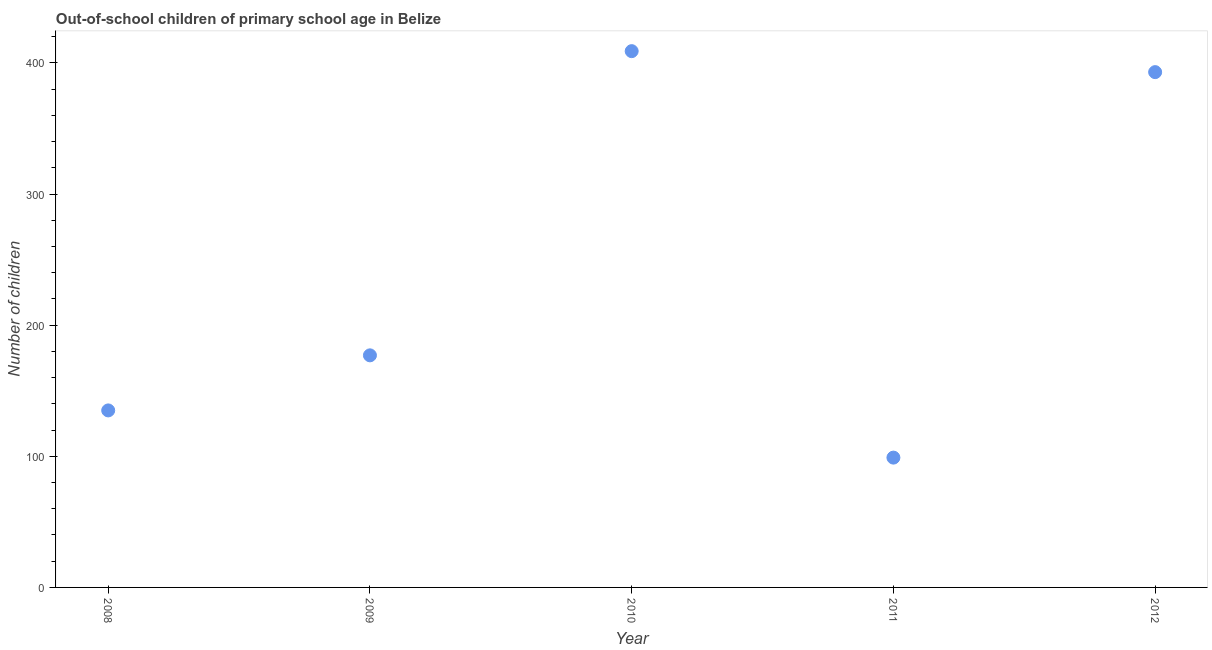What is the number of out-of-school children in 2010?
Give a very brief answer. 409. Across all years, what is the maximum number of out-of-school children?
Your answer should be compact. 409. Across all years, what is the minimum number of out-of-school children?
Provide a short and direct response. 99. In which year was the number of out-of-school children minimum?
Ensure brevity in your answer.  2011. What is the sum of the number of out-of-school children?
Your answer should be very brief. 1213. What is the difference between the number of out-of-school children in 2011 and 2012?
Your answer should be very brief. -294. What is the average number of out-of-school children per year?
Provide a succinct answer. 242.6. What is the median number of out-of-school children?
Keep it short and to the point. 177. In how many years, is the number of out-of-school children greater than 260 ?
Offer a very short reply. 2. What is the ratio of the number of out-of-school children in 2010 to that in 2011?
Provide a short and direct response. 4.13. What is the difference between the highest and the second highest number of out-of-school children?
Your answer should be very brief. 16. What is the difference between the highest and the lowest number of out-of-school children?
Provide a short and direct response. 310. In how many years, is the number of out-of-school children greater than the average number of out-of-school children taken over all years?
Provide a short and direct response. 2. Does the number of out-of-school children monotonically increase over the years?
Offer a very short reply. No. Are the values on the major ticks of Y-axis written in scientific E-notation?
Your response must be concise. No. Does the graph contain any zero values?
Give a very brief answer. No. What is the title of the graph?
Your answer should be very brief. Out-of-school children of primary school age in Belize. What is the label or title of the Y-axis?
Provide a succinct answer. Number of children. What is the Number of children in 2008?
Make the answer very short. 135. What is the Number of children in 2009?
Keep it short and to the point. 177. What is the Number of children in 2010?
Your answer should be very brief. 409. What is the Number of children in 2011?
Offer a very short reply. 99. What is the Number of children in 2012?
Provide a short and direct response. 393. What is the difference between the Number of children in 2008 and 2009?
Provide a succinct answer. -42. What is the difference between the Number of children in 2008 and 2010?
Make the answer very short. -274. What is the difference between the Number of children in 2008 and 2012?
Provide a succinct answer. -258. What is the difference between the Number of children in 2009 and 2010?
Ensure brevity in your answer.  -232. What is the difference between the Number of children in 2009 and 2011?
Offer a very short reply. 78. What is the difference between the Number of children in 2009 and 2012?
Give a very brief answer. -216. What is the difference between the Number of children in 2010 and 2011?
Provide a short and direct response. 310. What is the difference between the Number of children in 2010 and 2012?
Your answer should be compact. 16. What is the difference between the Number of children in 2011 and 2012?
Your response must be concise. -294. What is the ratio of the Number of children in 2008 to that in 2009?
Make the answer very short. 0.76. What is the ratio of the Number of children in 2008 to that in 2010?
Provide a succinct answer. 0.33. What is the ratio of the Number of children in 2008 to that in 2011?
Your response must be concise. 1.36. What is the ratio of the Number of children in 2008 to that in 2012?
Ensure brevity in your answer.  0.34. What is the ratio of the Number of children in 2009 to that in 2010?
Provide a short and direct response. 0.43. What is the ratio of the Number of children in 2009 to that in 2011?
Your answer should be very brief. 1.79. What is the ratio of the Number of children in 2009 to that in 2012?
Your answer should be very brief. 0.45. What is the ratio of the Number of children in 2010 to that in 2011?
Provide a short and direct response. 4.13. What is the ratio of the Number of children in 2010 to that in 2012?
Ensure brevity in your answer.  1.04. What is the ratio of the Number of children in 2011 to that in 2012?
Ensure brevity in your answer.  0.25. 